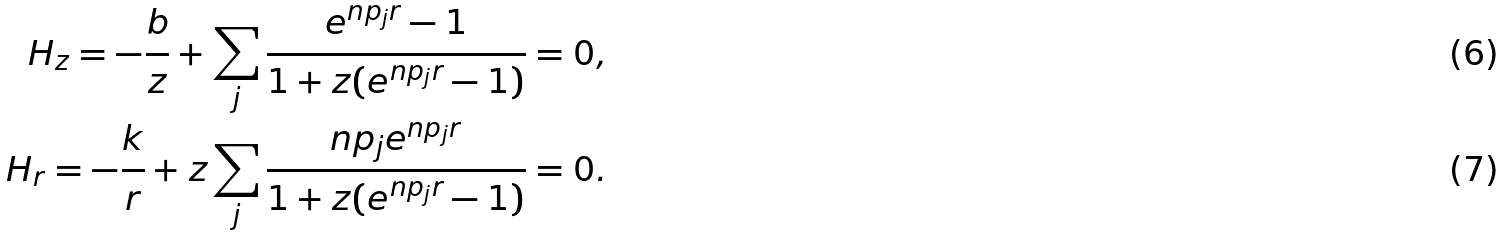<formula> <loc_0><loc_0><loc_500><loc_500>H _ { z } = - \frac { b } { z } + \sum _ { j } \frac { e ^ { n p _ { j } r } - 1 } { 1 + z ( e ^ { n p _ { j } r } - 1 ) } = 0 , \\ H _ { r } = - \frac { k } { r } + z \sum _ { j } \frac { n p _ { j } e ^ { n p _ { j } r } } { 1 + z ( e ^ { n p _ { j } r } - 1 ) } = 0 .</formula> 